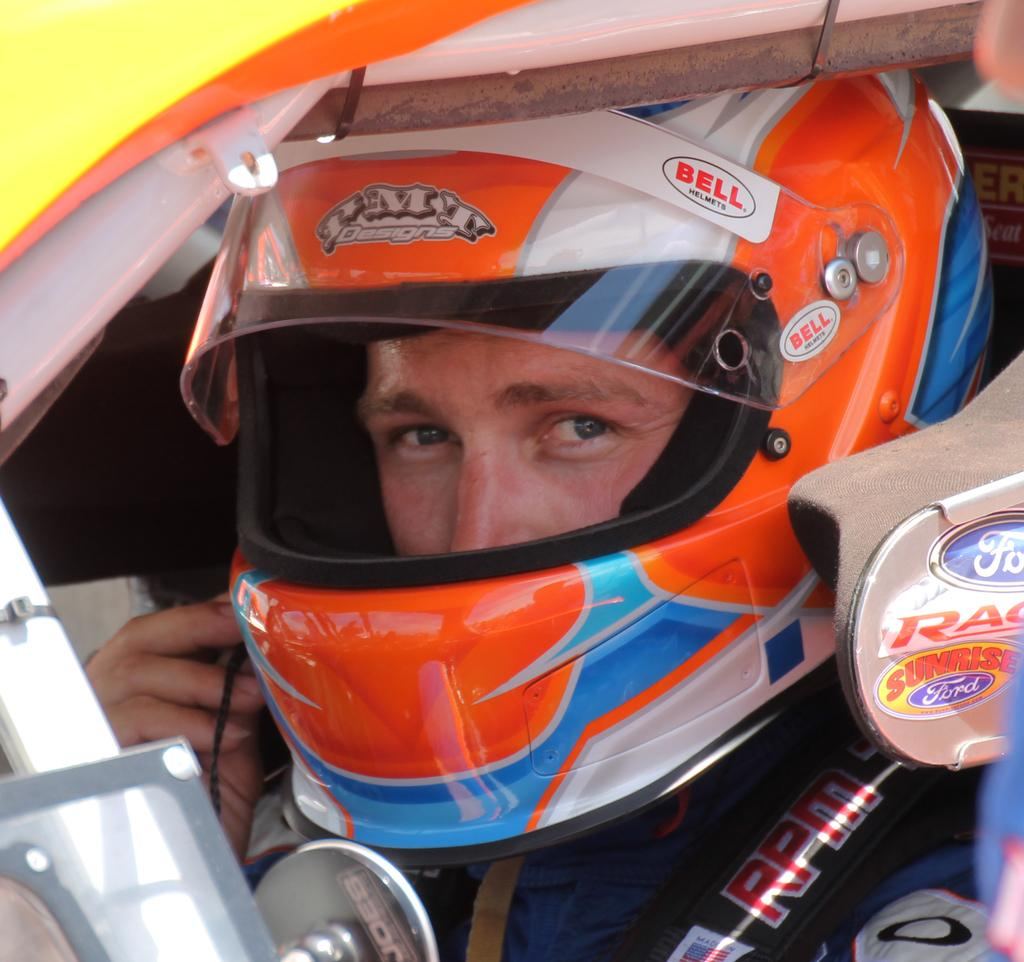Who or what is the main subject in the image? There is a person in the image. What is the person wearing in the image? The person is wearing a helmet. Where is the person located in the image? The person is visible in the foreground of the image. What is the strength of the current in the image? There is no reference to a current in the image, as it features a person wearing a helmet in the foreground. 